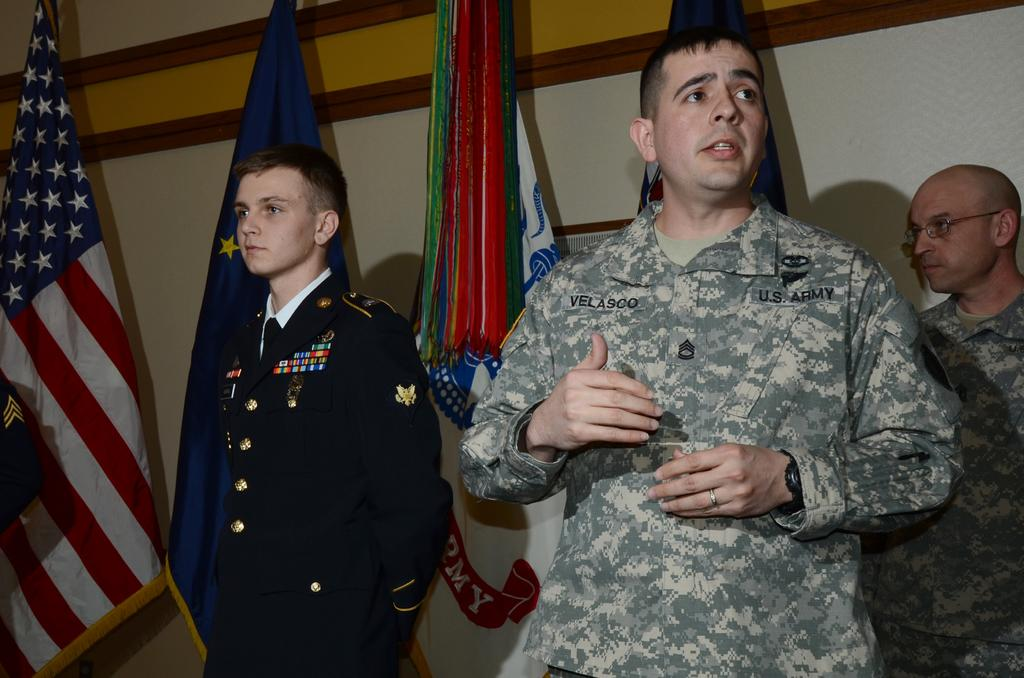How many men are present in the image? There are three men standing in the image. Where are the men positioned in the image? The men are standing towards the bottom of the image. What is one of the men doing in the image? There is a man talking in the image. What can be seen in the background of the image? There is a wall in the background of the image. What else is present in the image besides the men? There are flags in the image. Can you see any cobwebs hanging from the wall in the image? There is no mention of cobwebs in the image, so we cannot determine if any are present. 